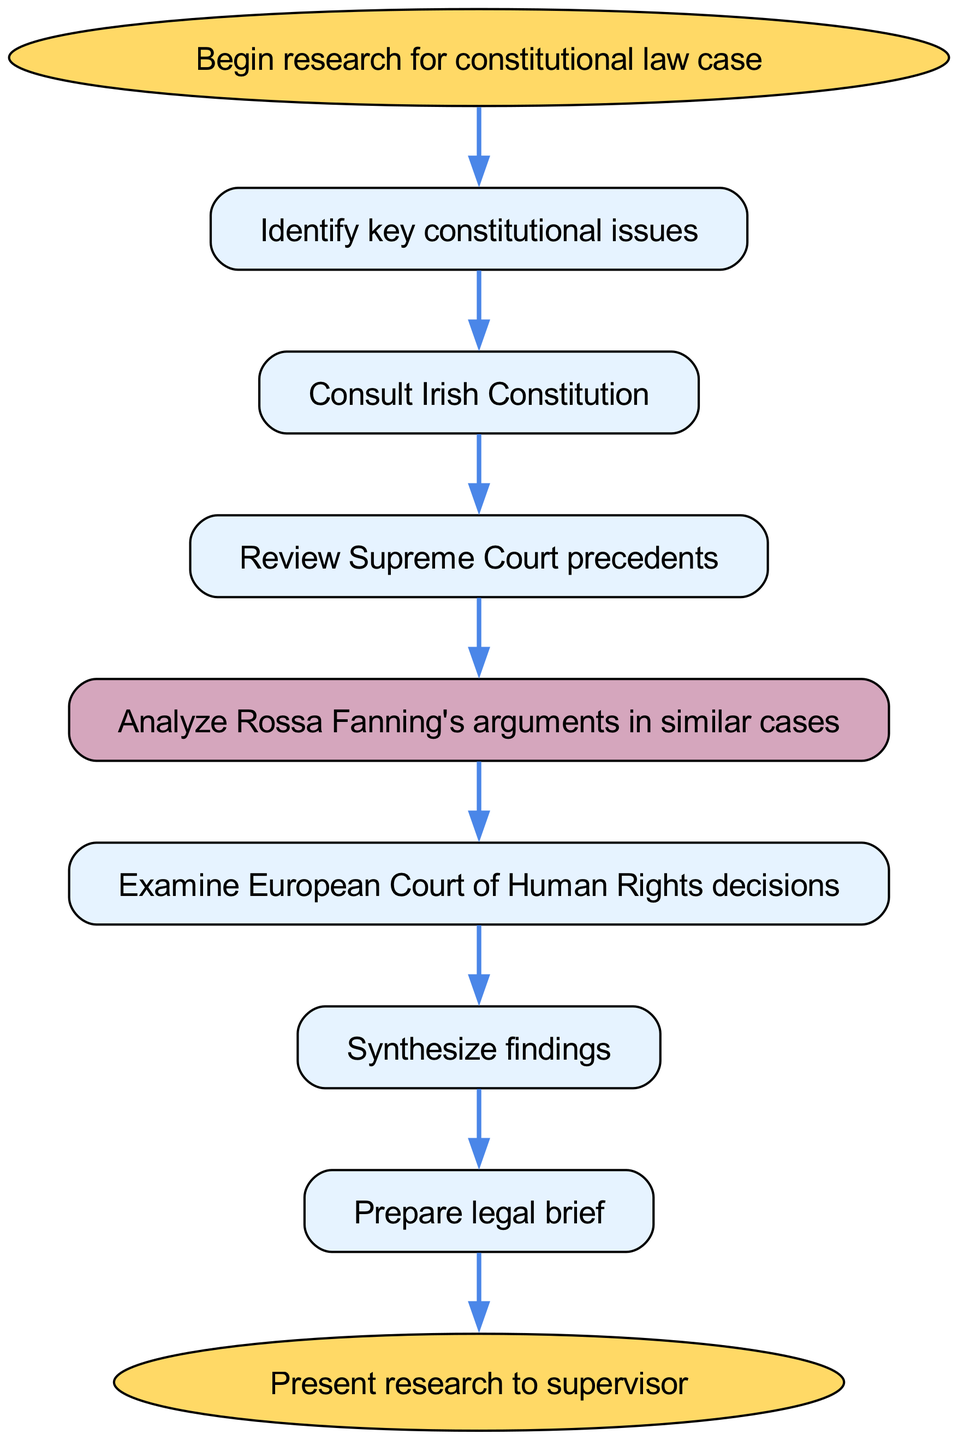What is the first step in the research process? The first step according to the diagram is identified as "Identify key constitutional issues," which is directly connected to the "Begin research for constitutional law case" node.
Answer: Identify key constitutional issues How many steps are there in total, excluding the start and end nodes? In the diagram, there are six steps from "Identify key constitutional issues" to "Prepare legal brief." Therefore, the count is taken from step 1 to step 7, minus the start and end nodes: 6 steps.
Answer: 6 What color is the node for analyzing Rossa Fanning's arguments? This specific node, "Analyze Rossa Fanning's arguments in similar cases," is colored with a distinct shade as indicated on the diagram—filled with the color #D5A6BD, which sets it apart from other nodes.
Answer: D5A6BD What step follows directly after reviewing Supreme Court precedents? The flow of the diagram indicates that the node "Review Supreme Court precedents" is followed directly by "Analyze Rossa Fanning's arguments in similar cases." This creates a direct sequence from one action to the next.
Answer: Analyze Rossa Fanning's arguments in similar cases Which node indicates the final action in the process? The final action, as outlined in the flow chart, is represented by the node "Present research to supervisor," which serves as the conclusion of the entire research process.
Answer: Present research to supervisor What is the relationship between examining European Court of Human Rights decisions and synthesizing findings? The flow chart shows that the node "Examine European Court of Human Rights decisions" is directly connected to "Synthesize findings," indicating that the results from the examination are to be synthesized immediately afterward.
Answer: Directly connected 